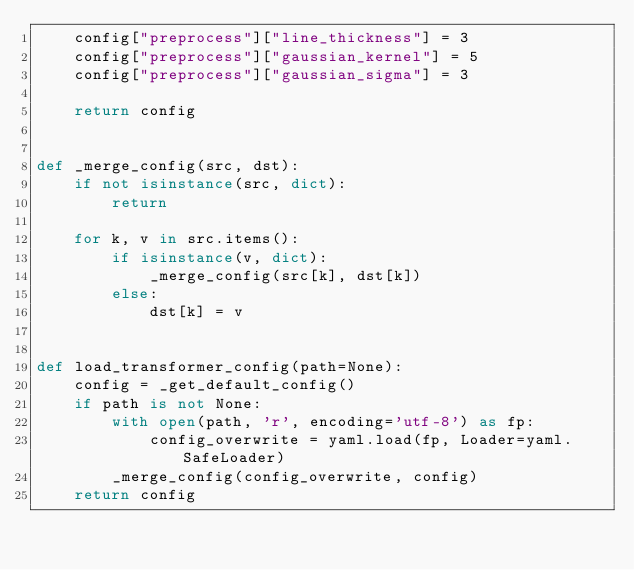<code> <loc_0><loc_0><loc_500><loc_500><_Python_>    config["preprocess"]["line_thickness"] = 3
    config["preprocess"]["gaussian_kernel"] = 5
    config["preprocess"]["gaussian_sigma"] = 3

    return config


def _merge_config(src, dst):
    if not isinstance(src, dict):
        return

    for k, v in src.items():
        if isinstance(v, dict):
            _merge_config(src[k], dst[k])
        else:
            dst[k] = v


def load_transformer_config(path=None):
    config = _get_default_config()
    if path is not None:
        with open(path, 'r', encoding='utf-8') as fp:
            config_overwrite = yaml.load(fp, Loader=yaml.SafeLoader)
        _merge_config(config_overwrite, config)
    return config
</code> 